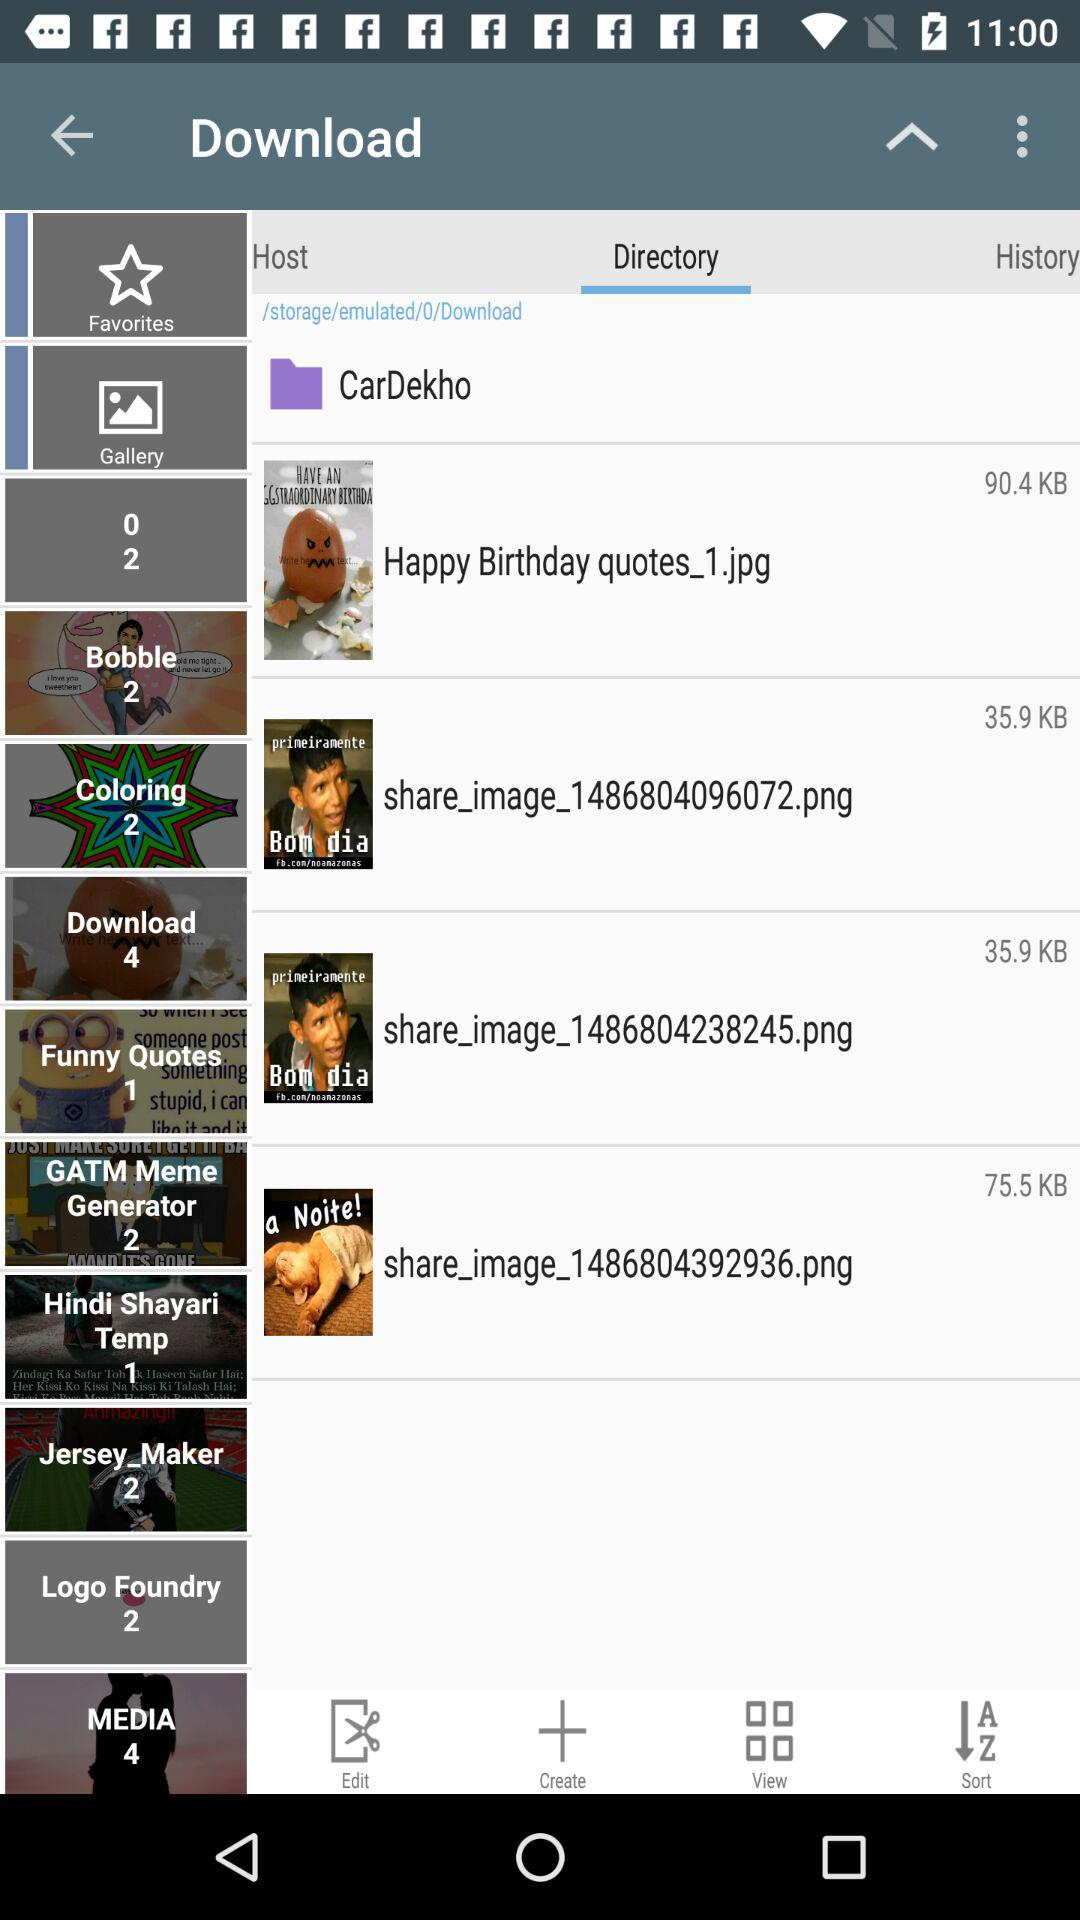What is the storage location of these saved images? The storage location is "/storage/emulated/0/Download". 